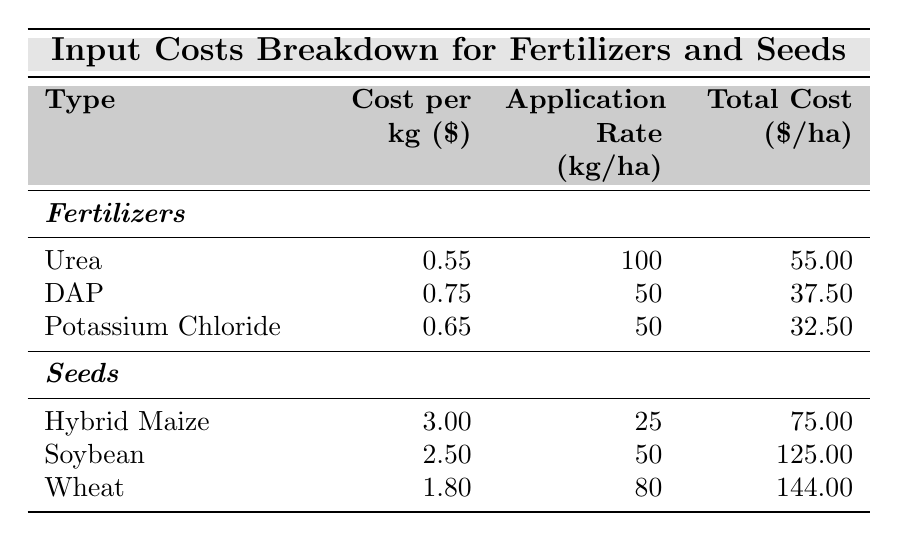What is the total cost per hectare for Urea? The total cost per hectare for Urea is explicitly listed in the table under the "Total Cost ($/ha)" column, which shows 55.00
Answer: 55.00 What is the cost per kg of Soybean seeds? The cost per kg for Soybean seeds can be found in the "Cost per kg ($)" column next to Soybean, which is 2.50
Answer: 2.50 Which fertilizer has the highest total cost per hectare? To determine which fertilizer has the highest total cost, we compare the "Total Cost ($/ha)" values in the Fertilizers section, Urea is 55.00, DAP is 37.50, and Potassium Chloride is 32.50. Urea has the highest cost.
Answer: Urea What is the average cost per kg for the fertilizers listed? The costs per kg for fertilizers are 0.55 (Urea), 0.75 (DAP), and 0.65 (Potassium Chloride). The average is calculated as (0.55 + 0.75 + 0.65) / 3 = 2.05 / 3 = 0.6833, rounding gives approximately 0.68
Answer: 0.68 Is the application rate for Wheat seeds greater than that of Hybrid Maize seeds? Wheat seeds have an application rate of 80 kg/ha, while Hybrid Maize seeds have an application rate of 25 kg/ha. Since 80 is greater than 25, the answer is yes.
Answer: Yes What is the combined total cost per hectare for all the fertilizers? We add the total costs for all fertilizers: Urea (55.00) + DAP (37.50) + Potassium Chloride (32.50) = 125.00
Answer: 125.00 What is the cheapest seed type based on cost per kg? The cheapest seed type can be identified by looking at the "Cost per kg ($)" column. Wheat seeds (1.80), Soybean seeds (2.50), and Hybrid Maize seeds (3.00) are compared. Wheat seeds have the lowest cost per kg.
Answer: Wheat seeds What is the difference in total cost per hectare between Soybean and Wheat seeds? The total cost for Soybean seeds is 125.00 and for Wheat seeds is 144.00. The difference is calculated as 144.00 - 125.00 = 19.00
Answer: 19.00 How much more does it cost per hectare to apply Hybrid Maize seeds compared to DAP fertilizer? The total cost per hectare for Hybrid Maize seeds is 75.00 and for DAP fertilizer is 37.50. The cost difference is calculated as 75.00 - 37.50 = 37.50.
Answer: 37.50 What percentage of the total cost for Wheat seeds contributes to the total input costs when all seeds and fertilizers are considered? The total input costs can be calculated by adding all the total costs from both sections: (55.00 + 37.50 + 32.50 + 75.00 + 125.00 + 144.00) = 469.00. Wheat's total cost is 144.00. The percentage contribution is (144.00 / 469.00) * 100 = 30.7%.
Answer: 30.7% 